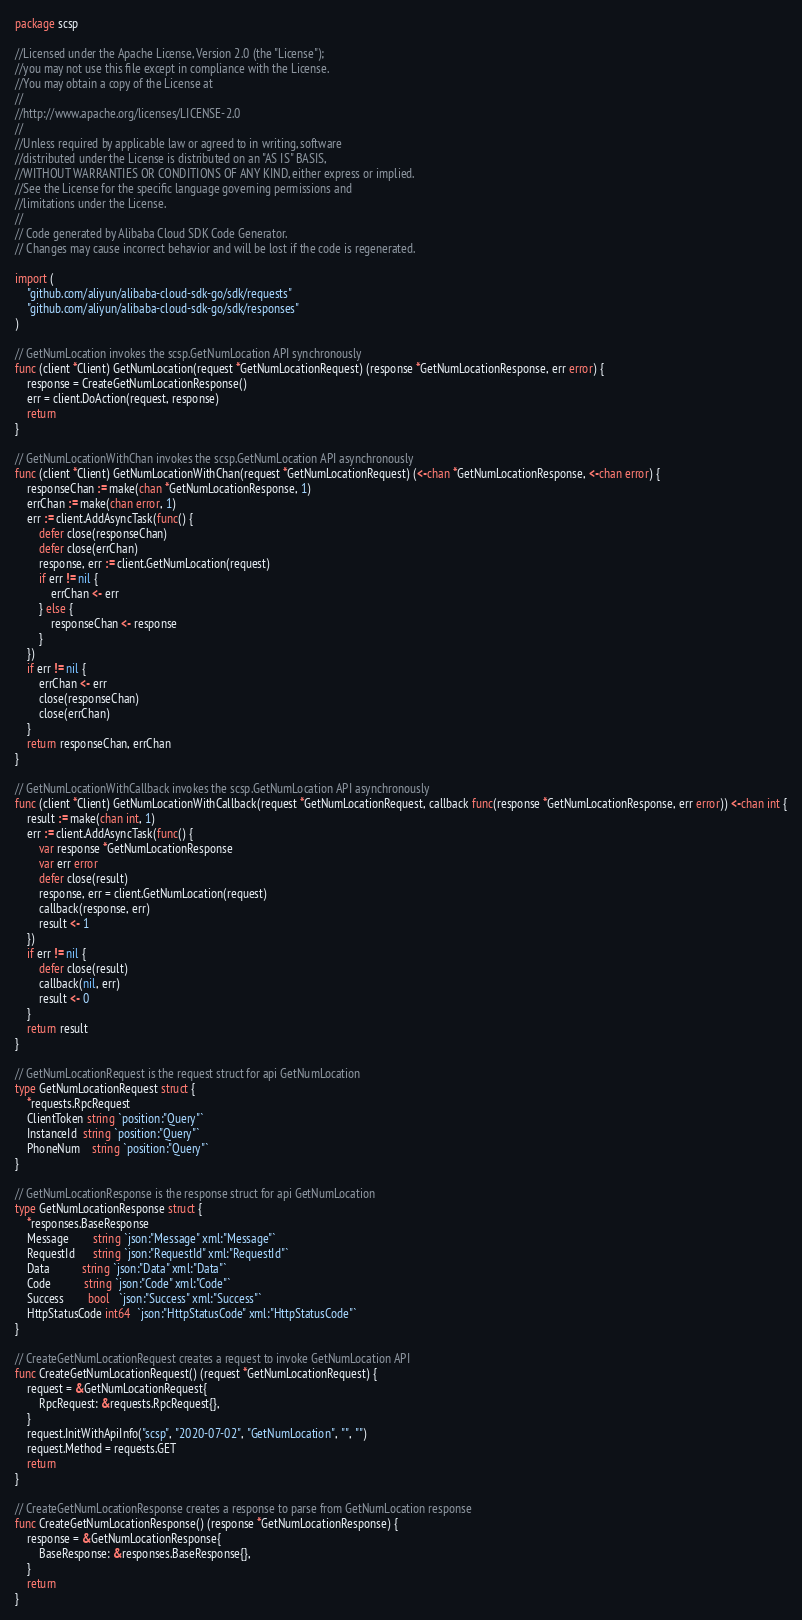Convert code to text. <code><loc_0><loc_0><loc_500><loc_500><_Go_>package scsp

//Licensed under the Apache License, Version 2.0 (the "License");
//you may not use this file except in compliance with the License.
//You may obtain a copy of the License at
//
//http://www.apache.org/licenses/LICENSE-2.0
//
//Unless required by applicable law or agreed to in writing, software
//distributed under the License is distributed on an "AS IS" BASIS,
//WITHOUT WARRANTIES OR CONDITIONS OF ANY KIND, either express or implied.
//See the License for the specific language governing permissions and
//limitations under the License.
//
// Code generated by Alibaba Cloud SDK Code Generator.
// Changes may cause incorrect behavior and will be lost if the code is regenerated.

import (
	"github.com/aliyun/alibaba-cloud-sdk-go/sdk/requests"
	"github.com/aliyun/alibaba-cloud-sdk-go/sdk/responses"
)

// GetNumLocation invokes the scsp.GetNumLocation API synchronously
func (client *Client) GetNumLocation(request *GetNumLocationRequest) (response *GetNumLocationResponse, err error) {
	response = CreateGetNumLocationResponse()
	err = client.DoAction(request, response)
	return
}

// GetNumLocationWithChan invokes the scsp.GetNumLocation API asynchronously
func (client *Client) GetNumLocationWithChan(request *GetNumLocationRequest) (<-chan *GetNumLocationResponse, <-chan error) {
	responseChan := make(chan *GetNumLocationResponse, 1)
	errChan := make(chan error, 1)
	err := client.AddAsyncTask(func() {
		defer close(responseChan)
		defer close(errChan)
		response, err := client.GetNumLocation(request)
		if err != nil {
			errChan <- err
		} else {
			responseChan <- response
		}
	})
	if err != nil {
		errChan <- err
		close(responseChan)
		close(errChan)
	}
	return responseChan, errChan
}

// GetNumLocationWithCallback invokes the scsp.GetNumLocation API asynchronously
func (client *Client) GetNumLocationWithCallback(request *GetNumLocationRequest, callback func(response *GetNumLocationResponse, err error)) <-chan int {
	result := make(chan int, 1)
	err := client.AddAsyncTask(func() {
		var response *GetNumLocationResponse
		var err error
		defer close(result)
		response, err = client.GetNumLocation(request)
		callback(response, err)
		result <- 1
	})
	if err != nil {
		defer close(result)
		callback(nil, err)
		result <- 0
	}
	return result
}

// GetNumLocationRequest is the request struct for api GetNumLocation
type GetNumLocationRequest struct {
	*requests.RpcRequest
	ClientToken string `position:"Query"`
	InstanceId  string `position:"Query"`
	PhoneNum    string `position:"Query"`
}

// GetNumLocationResponse is the response struct for api GetNumLocation
type GetNumLocationResponse struct {
	*responses.BaseResponse
	Message        string `json:"Message" xml:"Message"`
	RequestId      string `json:"RequestId" xml:"RequestId"`
	Data           string `json:"Data" xml:"Data"`
	Code           string `json:"Code" xml:"Code"`
	Success        bool   `json:"Success" xml:"Success"`
	HttpStatusCode int64  `json:"HttpStatusCode" xml:"HttpStatusCode"`
}

// CreateGetNumLocationRequest creates a request to invoke GetNumLocation API
func CreateGetNumLocationRequest() (request *GetNumLocationRequest) {
	request = &GetNumLocationRequest{
		RpcRequest: &requests.RpcRequest{},
	}
	request.InitWithApiInfo("scsp", "2020-07-02", "GetNumLocation", "", "")
	request.Method = requests.GET
	return
}

// CreateGetNumLocationResponse creates a response to parse from GetNumLocation response
func CreateGetNumLocationResponse() (response *GetNumLocationResponse) {
	response = &GetNumLocationResponse{
		BaseResponse: &responses.BaseResponse{},
	}
	return
}
</code> 